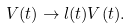Convert formula to latex. <formula><loc_0><loc_0><loc_500><loc_500>V ( t ) \rightarrow l ( t ) V ( t ) .</formula> 